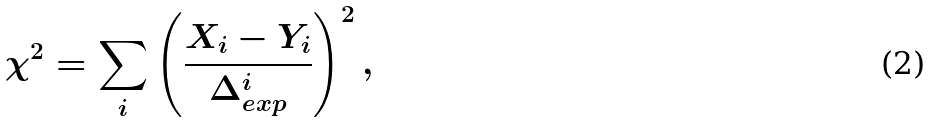Convert formula to latex. <formula><loc_0><loc_0><loc_500><loc_500>\chi ^ { 2 } = \sum _ { i } \left ( \frac { X _ { i } - Y _ { i } } { \Delta _ { e x p } ^ { i } } \right ) ^ { 2 } ,</formula> 